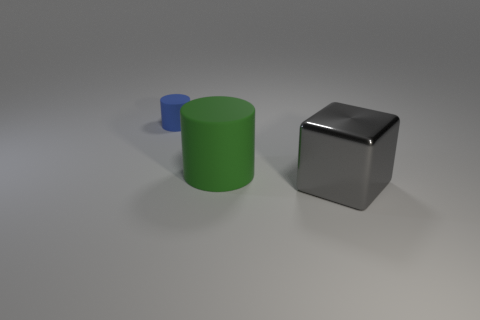Add 1 big green rubber spheres. How many objects exist? 4 Subtract all cubes. How many objects are left? 2 Add 3 yellow matte objects. How many yellow matte objects exist? 3 Subtract 1 blue cylinders. How many objects are left? 2 Subtract all cyan rubber cylinders. Subtract all blue rubber cylinders. How many objects are left? 2 Add 1 small blue cylinders. How many small blue cylinders are left? 2 